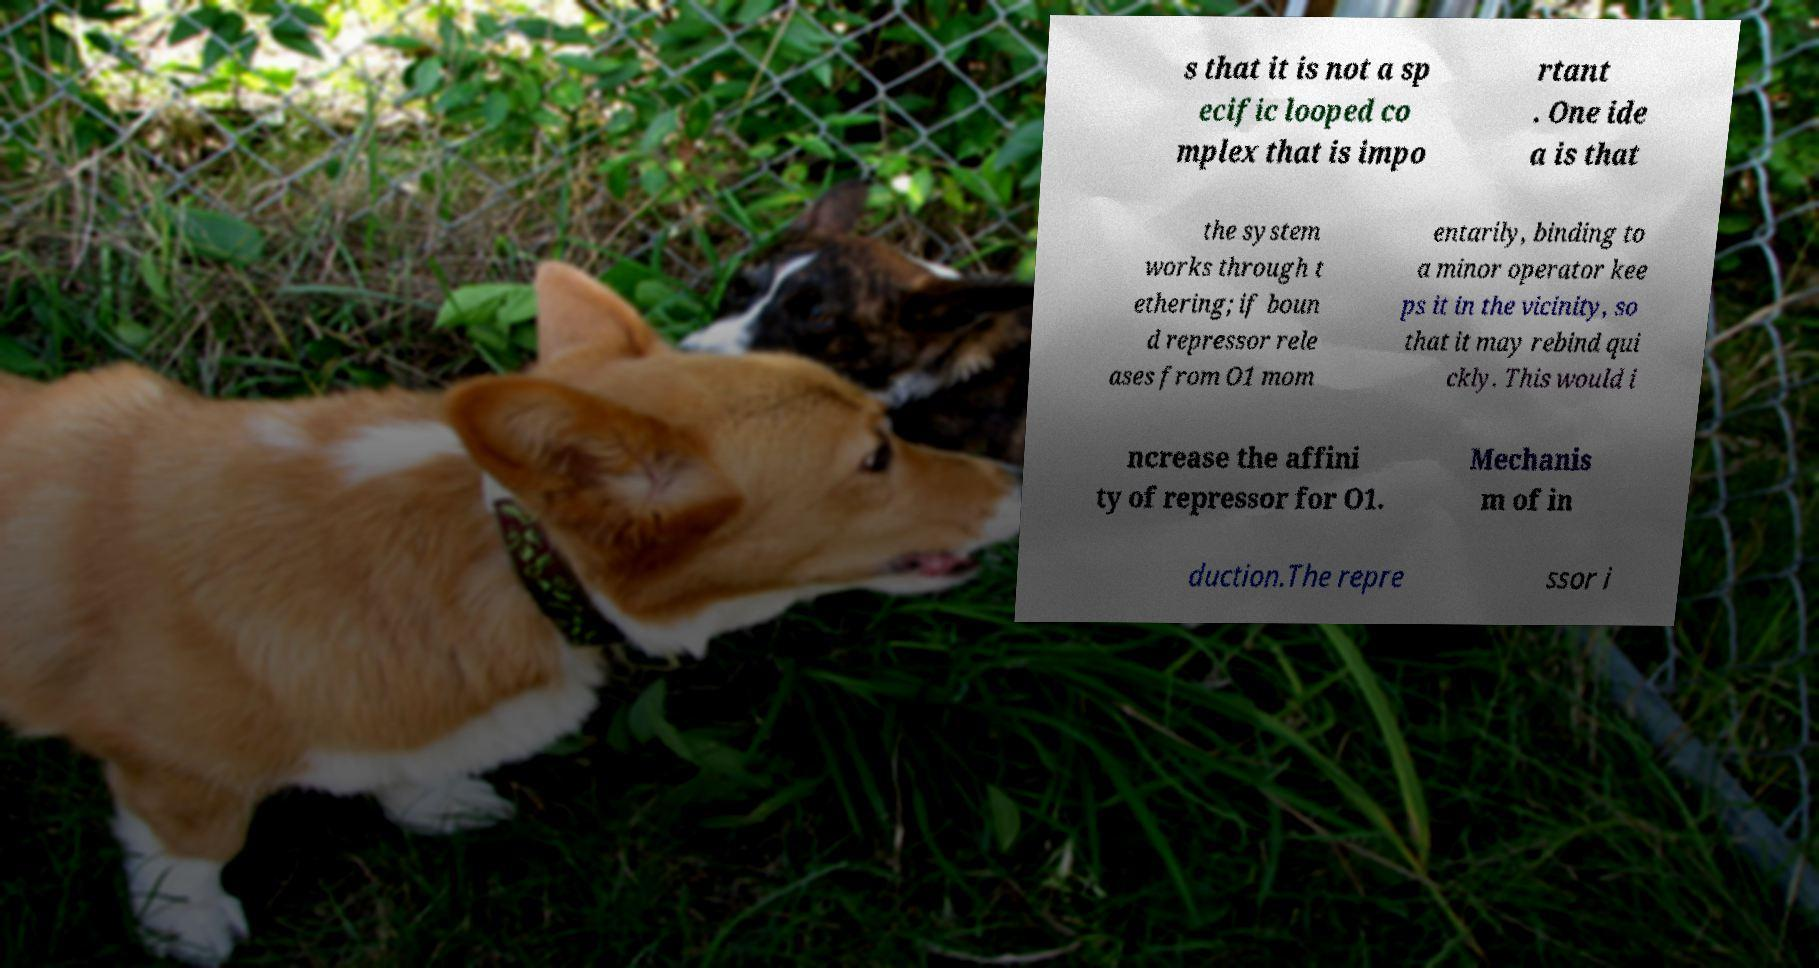There's text embedded in this image that I need extracted. Can you transcribe it verbatim? s that it is not a sp ecific looped co mplex that is impo rtant . One ide a is that the system works through t ethering; if boun d repressor rele ases from O1 mom entarily, binding to a minor operator kee ps it in the vicinity, so that it may rebind qui ckly. This would i ncrease the affini ty of repressor for O1. Mechanis m of in duction.The repre ssor i 